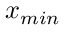Convert formula to latex. <formula><loc_0><loc_0><loc_500><loc_500>x _ { \min }</formula> 